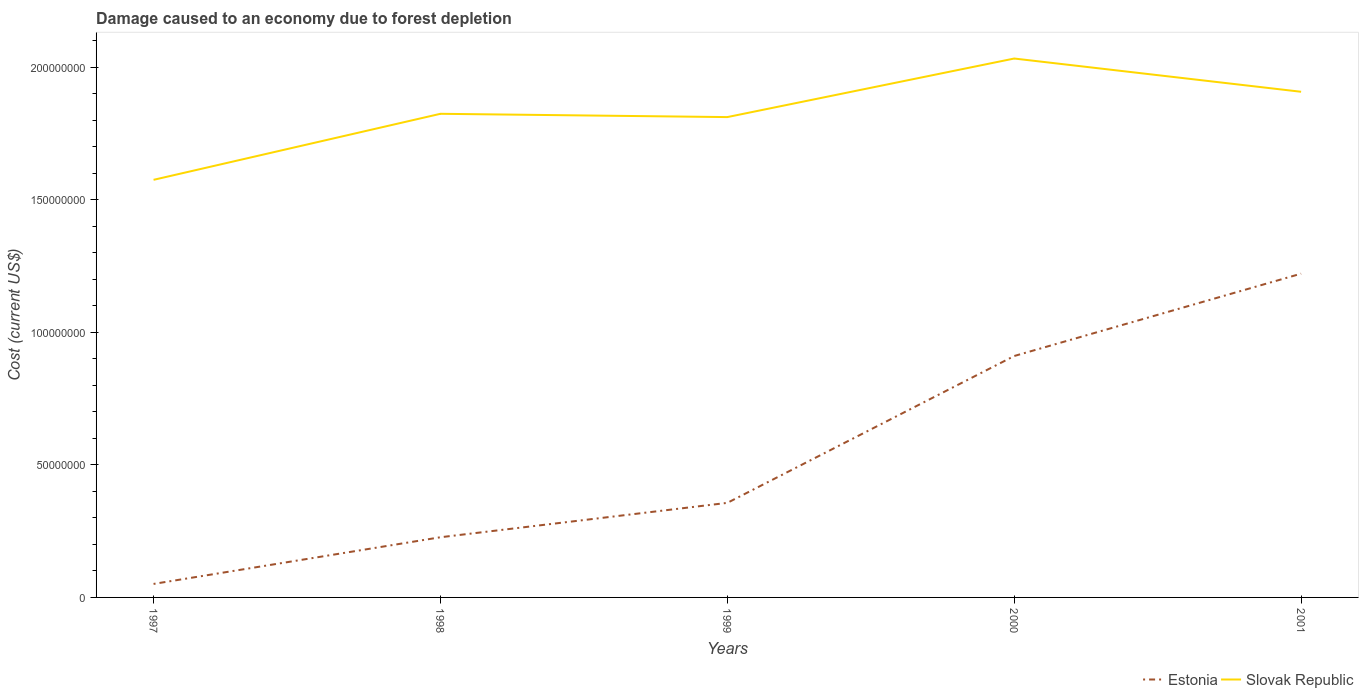How many different coloured lines are there?
Your answer should be very brief. 2. Is the number of lines equal to the number of legend labels?
Your answer should be compact. Yes. Across all years, what is the maximum cost of damage caused due to forest depletion in Estonia?
Provide a short and direct response. 5.09e+06. In which year was the cost of damage caused due to forest depletion in Estonia maximum?
Make the answer very short. 1997. What is the total cost of damage caused due to forest depletion in Slovak Republic in the graph?
Your answer should be very brief. -2.37e+07. What is the difference between the highest and the second highest cost of damage caused due to forest depletion in Estonia?
Provide a short and direct response. 1.17e+08. What is the difference between the highest and the lowest cost of damage caused due to forest depletion in Estonia?
Provide a succinct answer. 2. Is the cost of damage caused due to forest depletion in Estonia strictly greater than the cost of damage caused due to forest depletion in Slovak Republic over the years?
Provide a succinct answer. Yes. Does the graph contain grids?
Make the answer very short. No. Where does the legend appear in the graph?
Offer a very short reply. Bottom right. How many legend labels are there?
Ensure brevity in your answer.  2. How are the legend labels stacked?
Offer a very short reply. Horizontal. What is the title of the graph?
Provide a succinct answer. Damage caused to an economy due to forest depletion. Does "Angola" appear as one of the legend labels in the graph?
Provide a succinct answer. No. What is the label or title of the X-axis?
Your response must be concise. Years. What is the label or title of the Y-axis?
Your answer should be compact. Cost (current US$). What is the Cost (current US$) of Estonia in 1997?
Provide a succinct answer. 5.09e+06. What is the Cost (current US$) in Slovak Republic in 1997?
Provide a succinct answer. 1.58e+08. What is the Cost (current US$) of Estonia in 1998?
Provide a succinct answer. 2.27e+07. What is the Cost (current US$) in Slovak Republic in 1998?
Your answer should be compact. 1.82e+08. What is the Cost (current US$) of Estonia in 1999?
Offer a terse response. 3.57e+07. What is the Cost (current US$) of Slovak Republic in 1999?
Provide a succinct answer. 1.81e+08. What is the Cost (current US$) in Estonia in 2000?
Your answer should be compact. 9.11e+07. What is the Cost (current US$) in Slovak Republic in 2000?
Give a very brief answer. 2.03e+08. What is the Cost (current US$) of Estonia in 2001?
Provide a succinct answer. 1.22e+08. What is the Cost (current US$) of Slovak Republic in 2001?
Provide a succinct answer. 1.91e+08. Across all years, what is the maximum Cost (current US$) of Estonia?
Make the answer very short. 1.22e+08. Across all years, what is the maximum Cost (current US$) of Slovak Republic?
Give a very brief answer. 2.03e+08. Across all years, what is the minimum Cost (current US$) in Estonia?
Give a very brief answer. 5.09e+06. Across all years, what is the minimum Cost (current US$) in Slovak Republic?
Offer a terse response. 1.58e+08. What is the total Cost (current US$) in Estonia in the graph?
Give a very brief answer. 2.77e+08. What is the total Cost (current US$) of Slovak Republic in the graph?
Ensure brevity in your answer.  9.15e+08. What is the difference between the Cost (current US$) of Estonia in 1997 and that in 1998?
Provide a short and direct response. -1.76e+07. What is the difference between the Cost (current US$) in Slovak Republic in 1997 and that in 1998?
Offer a very short reply. -2.49e+07. What is the difference between the Cost (current US$) of Estonia in 1997 and that in 1999?
Your response must be concise. -3.06e+07. What is the difference between the Cost (current US$) in Slovak Republic in 1997 and that in 1999?
Keep it short and to the point. -2.37e+07. What is the difference between the Cost (current US$) in Estonia in 1997 and that in 2000?
Offer a very short reply. -8.60e+07. What is the difference between the Cost (current US$) in Slovak Republic in 1997 and that in 2000?
Your response must be concise. -4.58e+07. What is the difference between the Cost (current US$) of Estonia in 1997 and that in 2001?
Ensure brevity in your answer.  -1.17e+08. What is the difference between the Cost (current US$) of Slovak Republic in 1997 and that in 2001?
Provide a succinct answer. -3.32e+07. What is the difference between the Cost (current US$) in Estonia in 1998 and that in 1999?
Give a very brief answer. -1.30e+07. What is the difference between the Cost (current US$) in Slovak Republic in 1998 and that in 1999?
Provide a succinct answer. 1.24e+06. What is the difference between the Cost (current US$) in Estonia in 1998 and that in 2000?
Make the answer very short. -6.84e+07. What is the difference between the Cost (current US$) in Slovak Republic in 1998 and that in 2000?
Your response must be concise. -2.09e+07. What is the difference between the Cost (current US$) in Estonia in 1998 and that in 2001?
Ensure brevity in your answer.  -9.94e+07. What is the difference between the Cost (current US$) of Slovak Republic in 1998 and that in 2001?
Your answer should be compact. -8.31e+06. What is the difference between the Cost (current US$) in Estonia in 1999 and that in 2000?
Give a very brief answer. -5.54e+07. What is the difference between the Cost (current US$) of Slovak Republic in 1999 and that in 2000?
Keep it short and to the point. -2.21e+07. What is the difference between the Cost (current US$) in Estonia in 1999 and that in 2001?
Give a very brief answer. -8.65e+07. What is the difference between the Cost (current US$) in Slovak Republic in 1999 and that in 2001?
Ensure brevity in your answer.  -9.55e+06. What is the difference between the Cost (current US$) in Estonia in 2000 and that in 2001?
Keep it short and to the point. -3.11e+07. What is the difference between the Cost (current US$) of Slovak Republic in 2000 and that in 2001?
Offer a very short reply. 1.25e+07. What is the difference between the Cost (current US$) of Estonia in 1997 and the Cost (current US$) of Slovak Republic in 1998?
Provide a succinct answer. -1.77e+08. What is the difference between the Cost (current US$) in Estonia in 1997 and the Cost (current US$) in Slovak Republic in 1999?
Offer a terse response. -1.76e+08. What is the difference between the Cost (current US$) in Estonia in 1997 and the Cost (current US$) in Slovak Republic in 2000?
Give a very brief answer. -1.98e+08. What is the difference between the Cost (current US$) in Estonia in 1997 and the Cost (current US$) in Slovak Republic in 2001?
Your response must be concise. -1.86e+08. What is the difference between the Cost (current US$) of Estonia in 1998 and the Cost (current US$) of Slovak Republic in 1999?
Your response must be concise. -1.59e+08. What is the difference between the Cost (current US$) in Estonia in 1998 and the Cost (current US$) in Slovak Republic in 2000?
Give a very brief answer. -1.81e+08. What is the difference between the Cost (current US$) of Estonia in 1998 and the Cost (current US$) of Slovak Republic in 2001?
Your response must be concise. -1.68e+08. What is the difference between the Cost (current US$) in Estonia in 1999 and the Cost (current US$) in Slovak Republic in 2000?
Offer a terse response. -1.68e+08. What is the difference between the Cost (current US$) of Estonia in 1999 and the Cost (current US$) of Slovak Republic in 2001?
Your answer should be very brief. -1.55e+08. What is the difference between the Cost (current US$) of Estonia in 2000 and the Cost (current US$) of Slovak Republic in 2001?
Keep it short and to the point. -9.97e+07. What is the average Cost (current US$) in Estonia per year?
Offer a very short reply. 5.53e+07. What is the average Cost (current US$) in Slovak Republic per year?
Your answer should be compact. 1.83e+08. In the year 1997, what is the difference between the Cost (current US$) of Estonia and Cost (current US$) of Slovak Republic?
Offer a terse response. -1.52e+08. In the year 1998, what is the difference between the Cost (current US$) of Estonia and Cost (current US$) of Slovak Republic?
Provide a succinct answer. -1.60e+08. In the year 1999, what is the difference between the Cost (current US$) in Estonia and Cost (current US$) in Slovak Republic?
Make the answer very short. -1.46e+08. In the year 2000, what is the difference between the Cost (current US$) in Estonia and Cost (current US$) in Slovak Republic?
Your response must be concise. -1.12e+08. In the year 2001, what is the difference between the Cost (current US$) in Estonia and Cost (current US$) in Slovak Republic?
Your answer should be compact. -6.86e+07. What is the ratio of the Cost (current US$) of Estonia in 1997 to that in 1998?
Give a very brief answer. 0.22. What is the ratio of the Cost (current US$) of Slovak Republic in 1997 to that in 1998?
Offer a terse response. 0.86. What is the ratio of the Cost (current US$) in Estonia in 1997 to that in 1999?
Provide a succinct answer. 0.14. What is the ratio of the Cost (current US$) of Slovak Republic in 1997 to that in 1999?
Keep it short and to the point. 0.87. What is the ratio of the Cost (current US$) in Estonia in 1997 to that in 2000?
Provide a succinct answer. 0.06. What is the ratio of the Cost (current US$) of Slovak Republic in 1997 to that in 2000?
Give a very brief answer. 0.77. What is the ratio of the Cost (current US$) in Estonia in 1997 to that in 2001?
Give a very brief answer. 0.04. What is the ratio of the Cost (current US$) of Slovak Republic in 1997 to that in 2001?
Your response must be concise. 0.83. What is the ratio of the Cost (current US$) of Estonia in 1998 to that in 1999?
Your answer should be compact. 0.64. What is the ratio of the Cost (current US$) of Slovak Republic in 1998 to that in 1999?
Offer a terse response. 1.01. What is the ratio of the Cost (current US$) in Estonia in 1998 to that in 2000?
Ensure brevity in your answer.  0.25. What is the ratio of the Cost (current US$) of Slovak Republic in 1998 to that in 2000?
Offer a very short reply. 0.9. What is the ratio of the Cost (current US$) in Estonia in 1998 to that in 2001?
Ensure brevity in your answer.  0.19. What is the ratio of the Cost (current US$) of Slovak Republic in 1998 to that in 2001?
Offer a very short reply. 0.96. What is the ratio of the Cost (current US$) in Estonia in 1999 to that in 2000?
Ensure brevity in your answer.  0.39. What is the ratio of the Cost (current US$) of Slovak Republic in 1999 to that in 2000?
Make the answer very short. 0.89. What is the ratio of the Cost (current US$) of Estonia in 1999 to that in 2001?
Provide a short and direct response. 0.29. What is the ratio of the Cost (current US$) of Slovak Republic in 1999 to that in 2001?
Give a very brief answer. 0.95. What is the ratio of the Cost (current US$) in Estonia in 2000 to that in 2001?
Keep it short and to the point. 0.75. What is the ratio of the Cost (current US$) of Slovak Republic in 2000 to that in 2001?
Make the answer very short. 1.07. What is the difference between the highest and the second highest Cost (current US$) of Estonia?
Keep it short and to the point. 3.11e+07. What is the difference between the highest and the second highest Cost (current US$) of Slovak Republic?
Your answer should be compact. 1.25e+07. What is the difference between the highest and the lowest Cost (current US$) in Estonia?
Your answer should be very brief. 1.17e+08. What is the difference between the highest and the lowest Cost (current US$) of Slovak Republic?
Your answer should be very brief. 4.58e+07. 